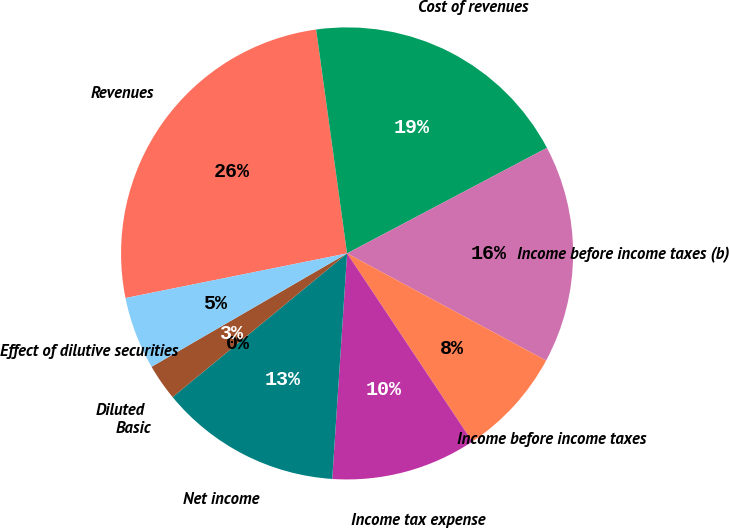Convert chart. <chart><loc_0><loc_0><loc_500><loc_500><pie_chart><fcel>Revenues<fcel>Cost of revenues<fcel>Income before income taxes (b)<fcel>Income before income taxes<fcel>Income tax expense<fcel>Net income<fcel>Basic<fcel>Diluted<fcel>Effect of dilutive securities<nl><fcel>25.98%<fcel>19.45%<fcel>15.59%<fcel>7.8%<fcel>10.39%<fcel>12.99%<fcel>0.0%<fcel>2.6%<fcel>5.2%<nl></chart> 